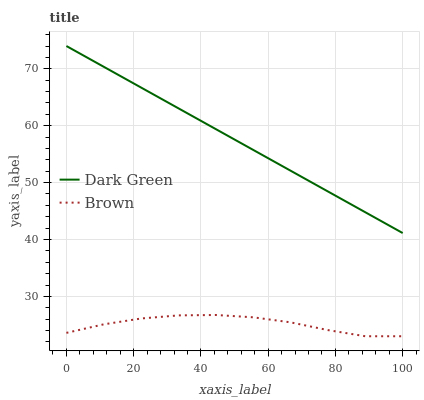Does Brown have the minimum area under the curve?
Answer yes or no. Yes. Does Dark Green have the maximum area under the curve?
Answer yes or no. Yes. Does Dark Green have the minimum area under the curve?
Answer yes or no. No. Is Dark Green the smoothest?
Answer yes or no. Yes. Is Brown the roughest?
Answer yes or no. Yes. Is Dark Green the roughest?
Answer yes or no. No. Does Dark Green have the lowest value?
Answer yes or no. No. Does Dark Green have the highest value?
Answer yes or no. Yes. Is Brown less than Dark Green?
Answer yes or no. Yes. Is Dark Green greater than Brown?
Answer yes or no. Yes. Does Brown intersect Dark Green?
Answer yes or no. No. 